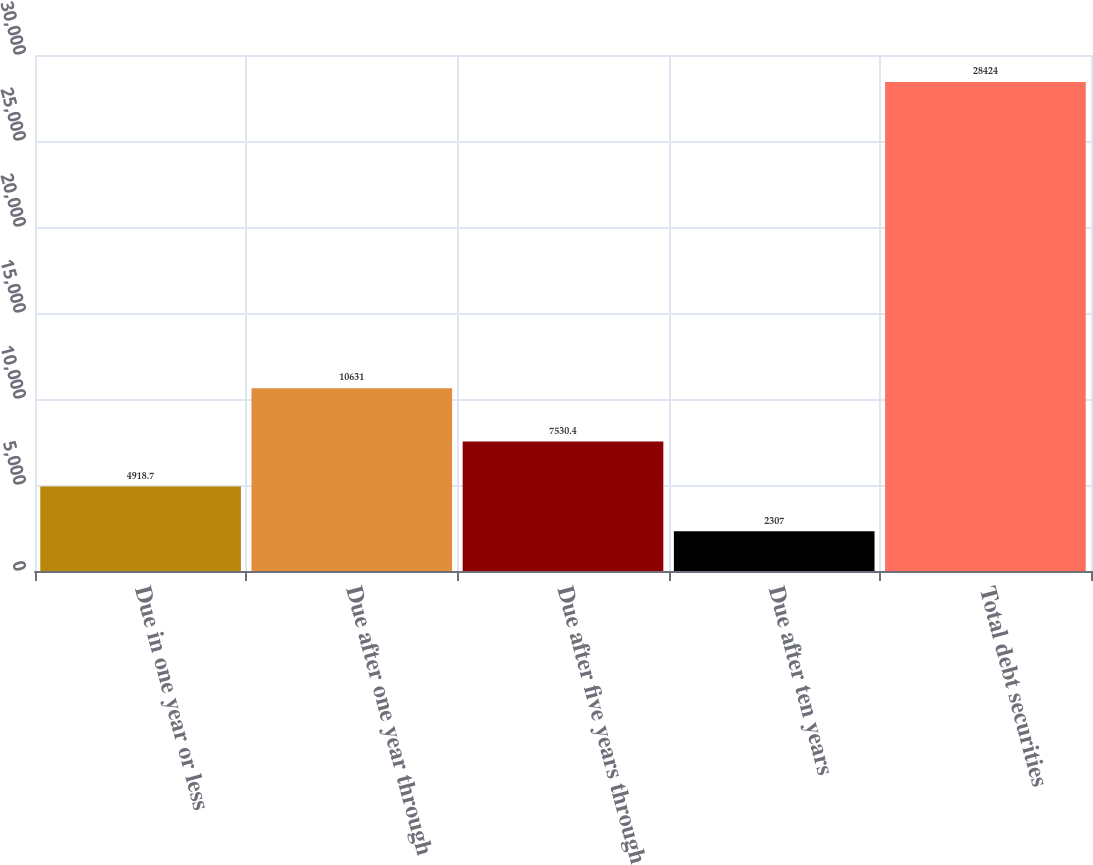Convert chart to OTSL. <chart><loc_0><loc_0><loc_500><loc_500><bar_chart><fcel>Due in one year or less<fcel>Due after one year through<fcel>Due after five years through<fcel>Due after ten years<fcel>Total debt securities<nl><fcel>4918.7<fcel>10631<fcel>7530.4<fcel>2307<fcel>28424<nl></chart> 